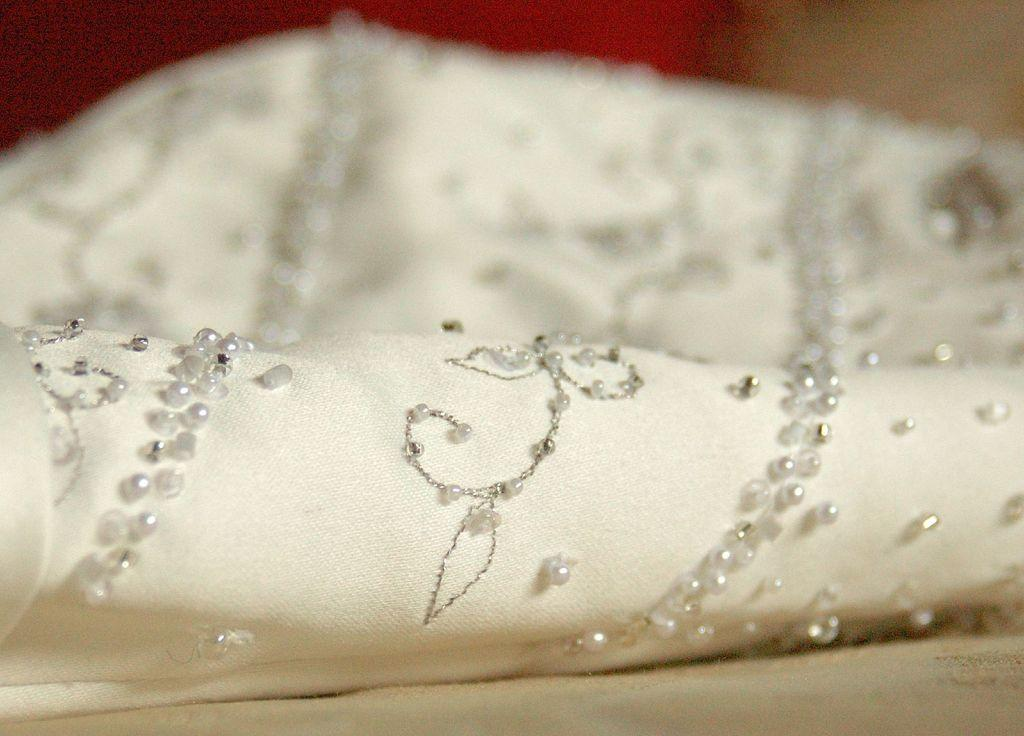What is the main object in the image? There is a white cloth with threads and beads in the image. What is the surface at the bottom of the image? The surface at the bottom of the image is not specified, but it could be a table or a floor. What can be seen at the top of the image? The top of the image has a blurred view, which could be due to a shallow depth of field or a focus issue. How many bells are attached to the sticks in the image? There are no bells or sticks present in the image; it features a white cloth with threads and beads. 